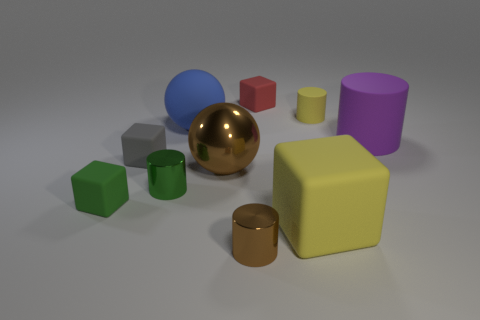How many yellow cylinders are there?
Offer a very short reply. 1. Do the big cube and the small matte cylinder have the same color?
Your answer should be compact. Yes. Is the number of small matte blocks that are in front of the brown shiny sphere less than the number of cubes to the left of the blue rubber thing?
Offer a terse response. Yes. The big metal thing is what color?
Ensure brevity in your answer.  Brown. What number of large rubber things have the same color as the small rubber cylinder?
Your response must be concise. 1. Are there any tiny rubber cubes behind the red rubber block?
Give a very brief answer. No. Are there the same number of big metal objects in front of the tiny brown shiny thing and small green rubber blocks that are behind the tiny yellow matte object?
Your response must be concise. Yes. Does the brown shiny object that is in front of the large brown sphere have the same size as the rubber cylinder that is behind the blue matte sphere?
Give a very brief answer. Yes. The yellow matte object behind the block on the right side of the tiny matte block behind the tiny rubber cylinder is what shape?
Your response must be concise. Cylinder. There is a red object that is the same shape as the large yellow thing; what size is it?
Offer a terse response. Small. 